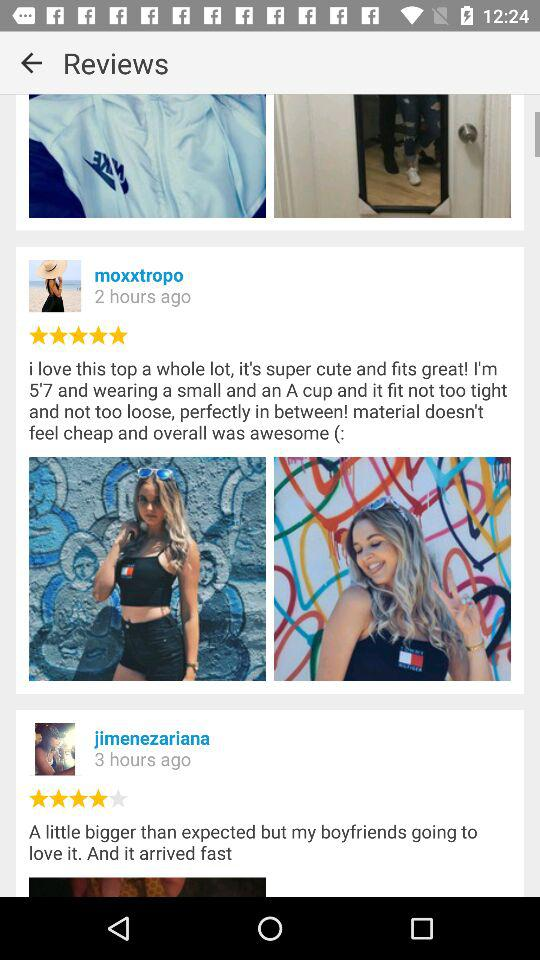How many hours ago did "jimenezariana" update a post? The post was updated 3 hours ago. 